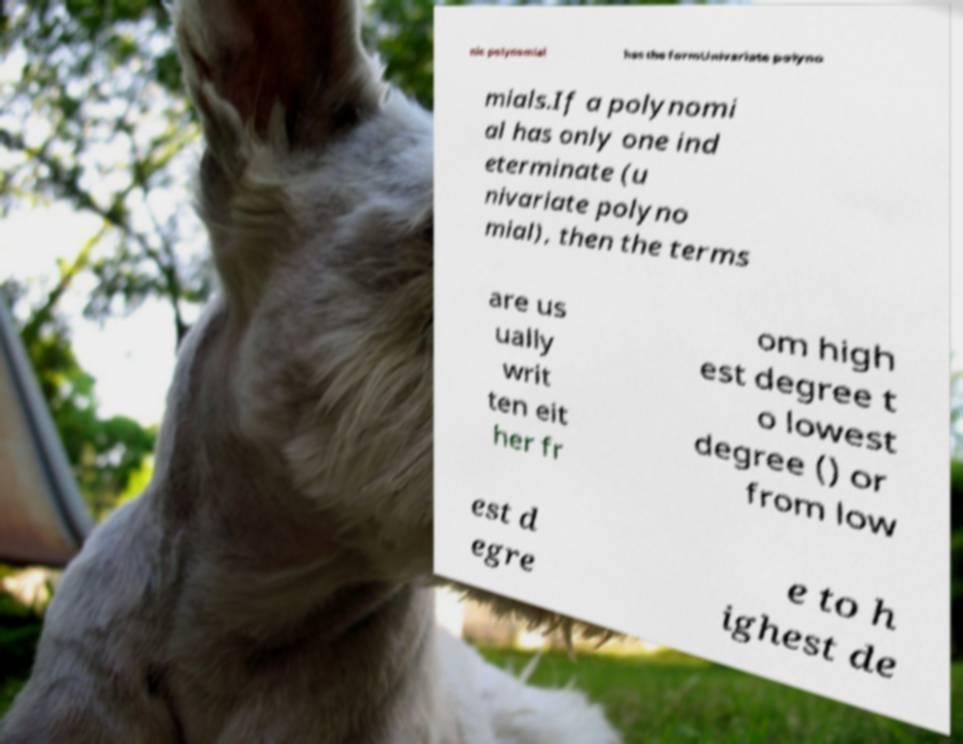For documentation purposes, I need the text within this image transcribed. Could you provide that? nic polynomial has the formUnivariate polyno mials.If a polynomi al has only one ind eterminate (u nivariate polyno mial), then the terms are us ually writ ten eit her fr om high est degree t o lowest degree () or from low est d egre e to h ighest de 